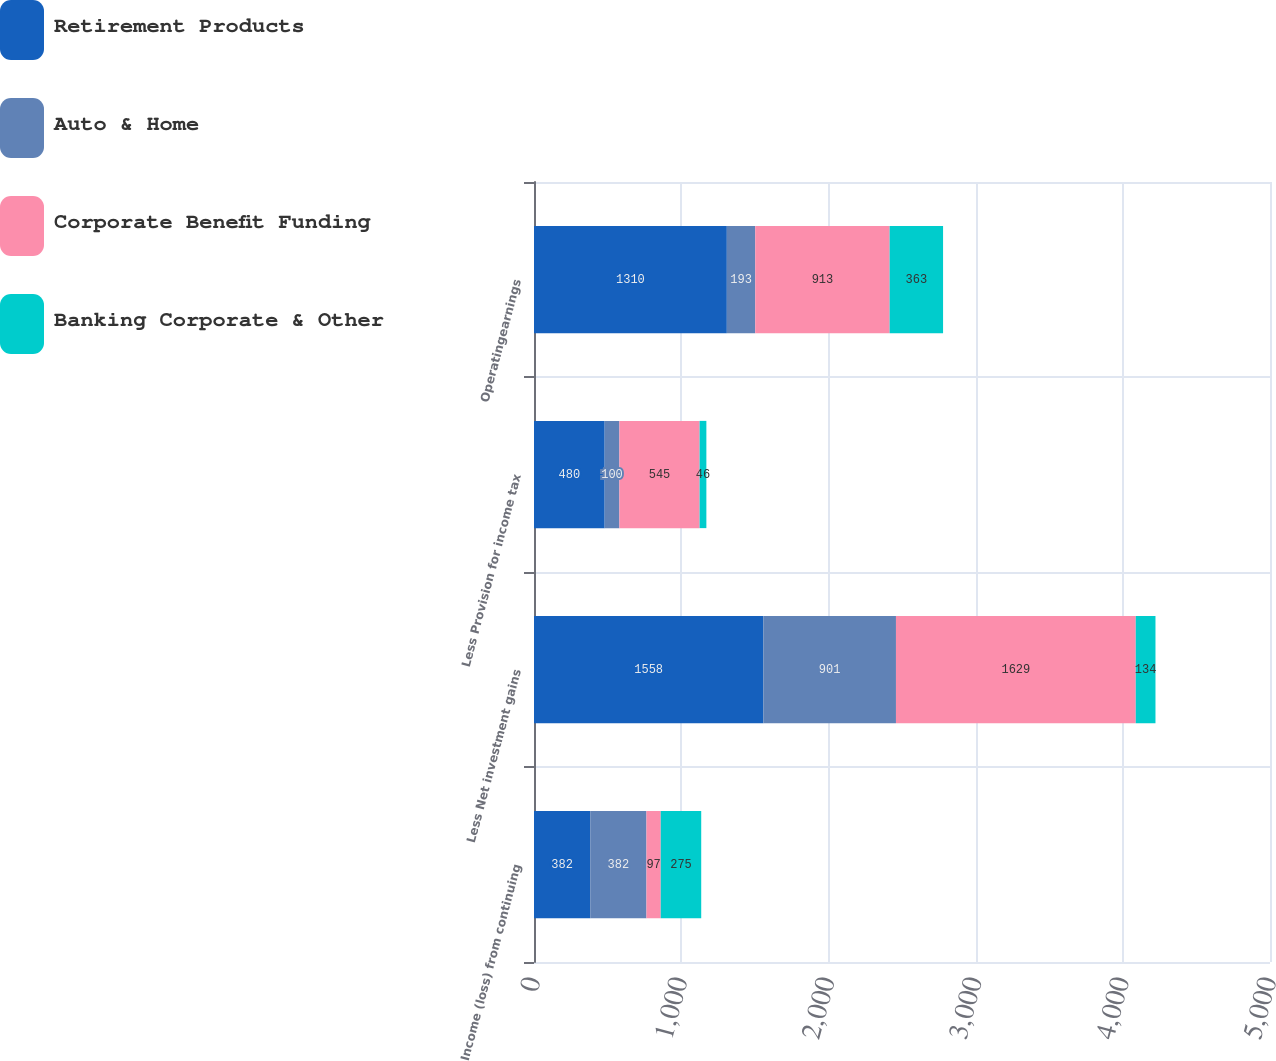Convert chart to OTSL. <chart><loc_0><loc_0><loc_500><loc_500><stacked_bar_chart><ecel><fcel>Income (loss) from continuing<fcel>Less Net investment gains<fcel>Less Provision for income tax<fcel>Operatingearnings<nl><fcel>Retirement Products<fcel>382<fcel>1558<fcel>480<fcel>1310<nl><fcel>Auto & Home<fcel>382<fcel>901<fcel>100<fcel>193<nl><fcel>Corporate Benefit Funding<fcel>97<fcel>1629<fcel>545<fcel>913<nl><fcel>Banking Corporate & Other<fcel>275<fcel>134<fcel>46<fcel>363<nl></chart> 